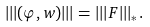<formula> <loc_0><loc_0><loc_500><loc_500>| | | ( \varphi , w ) | | | = | | | F | | | _ { * } .</formula> 